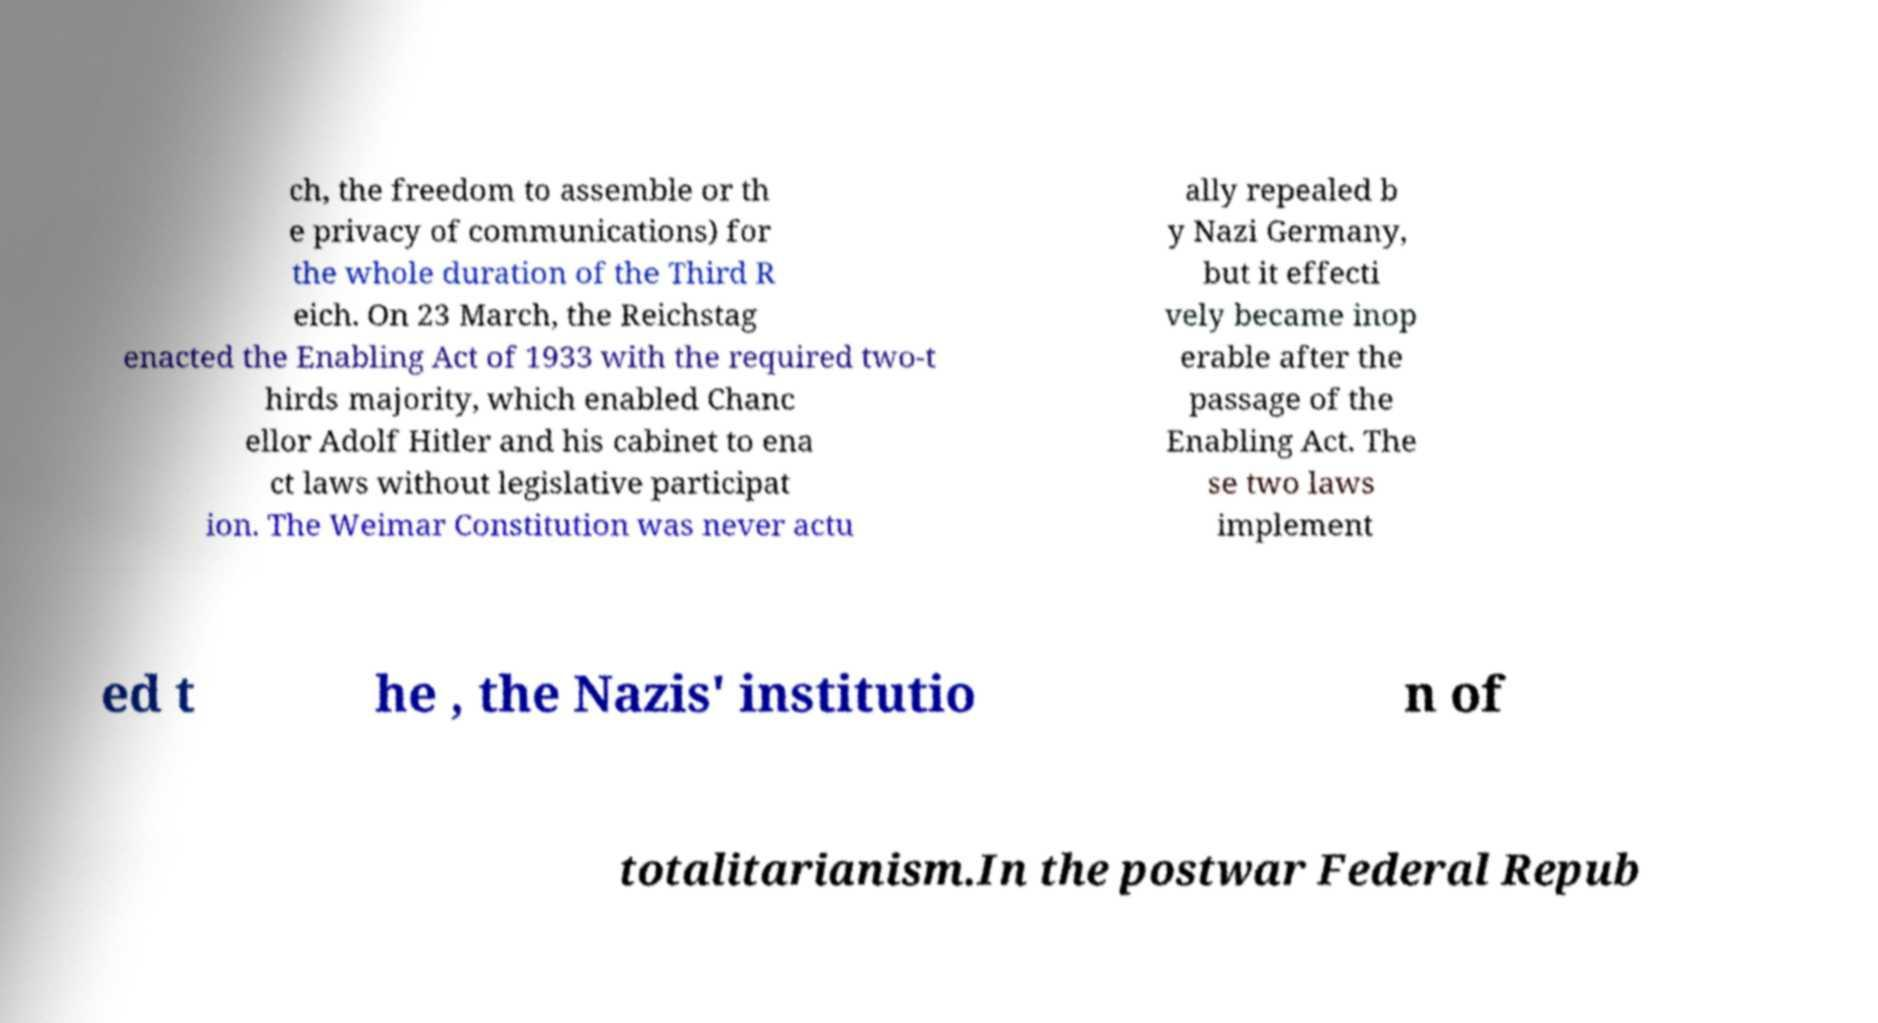Can you accurately transcribe the text from the provided image for me? ch, the freedom to assemble or th e privacy of communications) for the whole duration of the Third R eich. On 23 March, the Reichstag enacted the Enabling Act of 1933 with the required two-t hirds majority, which enabled Chanc ellor Adolf Hitler and his cabinet to ena ct laws without legislative participat ion. The Weimar Constitution was never actu ally repealed b y Nazi Germany, but it effecti vely became inop erable after the passage of the Enabling Act. The se two laws implement ed t he , the Nazis' institutio n of totalitarianism.In the postwar Federal Repub 